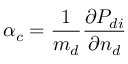<formula> <loc_0><loc_0><loc_500><loc_500>\alpha _ { c } = \frac { 1 } { m _ { d } } \frac { \partial P _ { d i } } { \partial n _ { d } }</formula> 